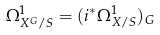<formula> <loc_0><loc_0><loc_500><loc_500>\Omega ^ { 1 } _ { X ^ { G } / S } = ( i ^ { * } \Omega ^ { 1 } _ { X / S } ) _ { G }</formula> 